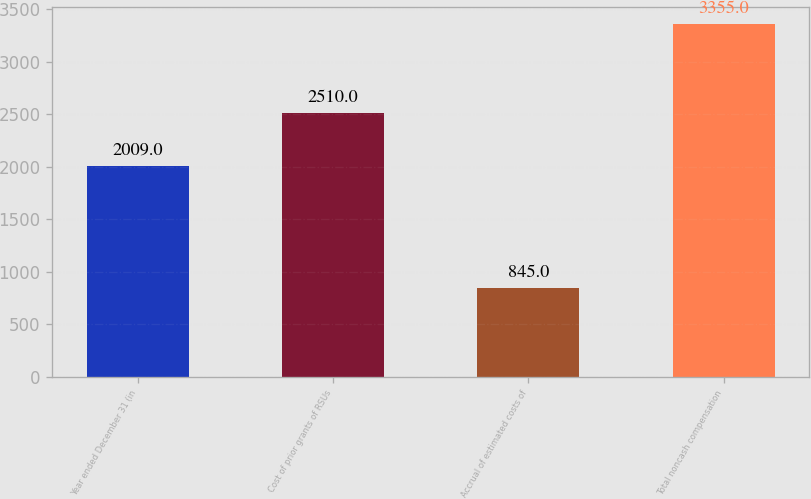Convert chart. <chart><loc_0><loc_0><loc_500><loc_500><bar_chart><fcel>Year ended December 31 (in<fcel>Cost of prior grants of RSUs<fcel>Accrual of estimated costs of<fcel>Total noncash compensation<nl><fcel>2009<fcel>2510<fcel>845<fcel>3355<nl></chart> 